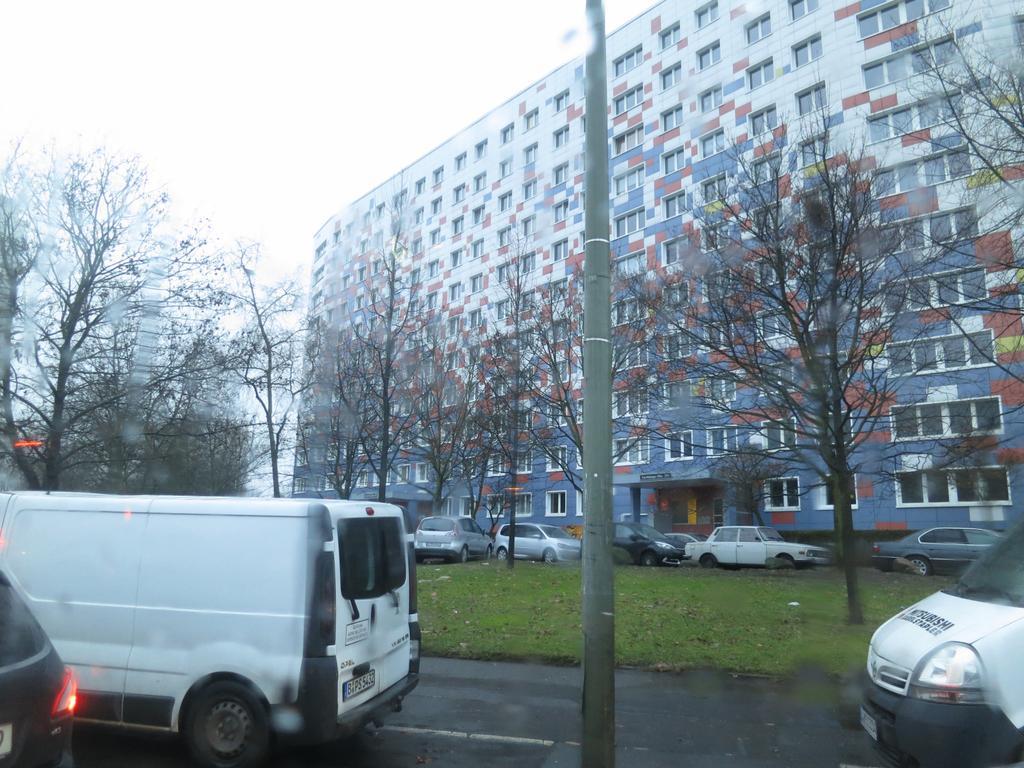How would you summarize this image in a sentence or two? In this image there are vehicles moving on road, there is a pole, in the background there are trees, cars and big building. 